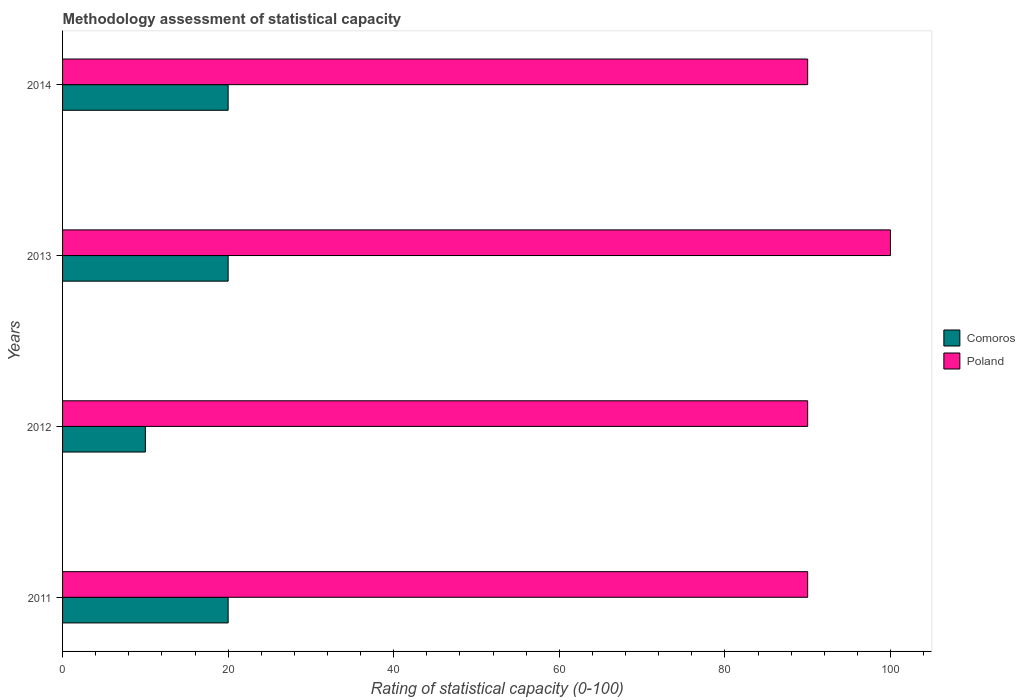How many different coloured bars are there?
Keep it short and to the point. 2. What is the rating of statistical capacity in Poland in 2011?
Keep it short and to the point. 90. In which year was the rating of statistical capacity in Comoros maximum?
Your response must be concise. 2011. In which year was the rating of statistical capacity in Comoros minimum?
Your answer should be compact. 2012. What is the total rating of statistical capacity in Comoros in the graph?
Ensure brevity in your answer.  70. What is the difference between the rating of statistical capacity in Comoros in 2013 and the rating of statistical capacity in Poland in 2012?
Your response must be concise. -70. What is the average rating of statistical capacity in Comoros per year?
Your answer should be very brief. 17.5. What is the difference between the highest and the second highest rating of statistical capacity in Poland?
Provide a succinct answer. 10. What is the difference between the highest and the lowest rating of statistical capacity in Comoros?
Offer a very short reply. 10. In how many years, is the rating of statistical capacity in Comoros greater than the average rating of statistical capacity in Comoros taken over all years?
Give a very brief answer. 3. What does the 2nd bar from the top in 2013 represents?
Make the answer very short. Comoros. What does the 2nd bar from the bottom in 2011 represents?
Keep it short and to the point. Poland. Where does the legend appear in the graph?
Provide a short and direct response. Center right. What is the title of the graph?
Provide a succinct answer. Methodology assessment of statistical capacity. Does "Maldives" appear as one of the legend labels in the graph?
Offer a very short reply. No. What is the label or title of the X-axis?
Your answer should be compact. Rating of statistical capacity (0-100). What is the Rating of statistical capacity (0-100) of Poland in 2011?
Your response must be concise. 90. What is the Rating of statistical capacity (0-100) in Comoros in 2012?
Give a very brief answer. 10. What is the Rating of statistical capacity (0-100) in Comoros in 2013?
Provide a short and direct response. 20. What is the Rating of statistical capacity (0-100) of Poland in 2013?
Your answer should be compact. 100. What is the Rating of statistical capacity (0-100) of Comoros in 2014?
Your answer should be very brief. 20. Across all years, what is the maximum Rating of statistical capacity (0-100) of Comoros?
Offer a terse response. 20. Across all years, what is the minimum Rating of statistical capacity (0-100) of Comoros?
Provide a succinct answer. 10. Across all years, what is the minimum Rating of statistical capacity (0-100) in Poland?
Provide a succinct answer. 90. What is the total Rating of statistical capacity (0-100) of Comoros in the graph?
Provide a succinct answer. 70. What is the total Rating of statistical capacity (0-100) of Poland in the graph?
Ensure brevity in your answer.  370. What is the difference between the Rating of statistical capacity (0-100) of Poland in 2011 and that in 2012?
Provide a succinct answer. 0. What is the difference between the Rating of statistical capacity (0-100) in Comoros in 2011 and that in 2013?
Offer a very short reply. 0. What is the difference between the Rating of statistical capacity (0-100) of Poland in 2012 and that in 2013?
Your response must be concise. -10. What is the difference between the Rating of statistical capacity (0-100) of Comoros in 2012 and that in 2014?
Your response must be concise. -10. What is the difference between the Rating of statistical capacity (0-100) in Poland in 2012 and that in 2014?
Give a very brief answer. 0. What is the difference between the Rating of statistical capacity (0-100) of Comoros in 2013 and that in 2014?
Make the answer very short. 0. What is the difference between the Rating of statistical capacity (0-100) of Poland in 2013 and that in 2014?
Keep it short and to the point. 10. What is the difference between the Rating of statistical capacity (0-100) of Comoros in 2011 and the Rating of statistical capacity (0-100) of Poland in 2012?
Your answer should be compact. -70. What is the difference between the Rating of statistical capacity (0-100) of Comoros in 2011 and the Rating of statistical capacity (0-100) of Poland in 2013?
Keep it short and to the point. -80. What is the difference between the Rating of statistical capacity (0-100) in Comoros in 2011 and the Rating of statistical capacity (0-100) in Poland in 2014?
Offer a very short reply. -70. What is the difference between the Rating of statistical capacity (0-100) of Comoros in 2012 and the Rating of statistical capacity (0-100) of Poland in 2013?
Your response must be concise. -90. What is the difference between the Rating of statistical capacity (0-100) of Comoros in 2012 and the Rating of statistical capacity (0-100) of Poland in 2014?
Your response must be concise. -80. What is the difference between the Rating of statistical capacity (0-100) of Comoros in 2013 and the Rating of statistical capacity (0-100) of Poland in 2014?
Offer a terse response. -70. What is the average Rating of statistical capacity (0-100) in Comoros per year?
Ensure brevity in your answer.  17.5. What is the average Rating of statistical capacity (0-100) of Poland per year?
Your answer should be very brief. 92.5. In the year 2011, what is the difference between the Rating of statistical capacity (0-100) of Comoros and Rating of statistical capacity (0-100) of Poland?
Give a very brief answer. -70. In the year 2012, what is the difference between the Rating of statistical capacity (0-100) of Comoros and Rating of statistical capacity (0-100) of Poland?
Your response must be concise. -80. In the year 2013, what is the difference between the Rating of statistical capacity (0-100) in Comoros and Rating of statistical capacity (0-100) in Poland?
Make the answer very short. -80. In the year 2014, what is the difference between the Rating of statistical capacity (0-100) in Comoros and Rating of statistical capacity (0-100) in Poland?
Your answer should be very brief. -70. What is the ratio of the Rating of statistical capacity (0-100) of Comoros in 2011 to that in 2013?
Provide a short and direct response. 1. What is the ratio of the Rating of statistical capacity (0-100) of Comoros in 2011 to that in 2014?
Ensure brevity in your answer.  1. What is the ratio of the Rating of statistical capacity (0-100) in Poland in 2011 to that in 2014?
Provide a short and direct response. 1. What is the ratio of the Rating of statistical capacity (0-100) in Poland in 2012 to that in 2013?
Offer a very short reply. 0.9. What is the ratio of the Rating of statistical capacity (0-100) in Comoros in 2012 to that in 2014?
Your response must be concise. 0.5. What is the ratio of the Rating of statistical capacity (0-100) of Poland in 2013 to that in 2014?
Your answer should be very brief. 1.11. What is the difference between the highest and the second highest Rating of statistical capacity (0-100) of Poland?
Offer a terse response. 10. What is the difference between the highest and the lowest Rating of statistical capacity (0-100) of Comoros?
Your answer should be compact. 10. What is the difference between the highest and the lowest Rating of statistical capacity (0-100) in Poland?
Offer a very short reply. 10. 